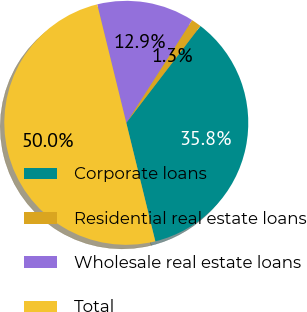Convert chart to OTSL. <chart><loc_0><loc_0><loc_500><loc_500><pie_chart><fcel>Corporate loans<fcel>Residential real estate loans<fcel>Wholesale real estate loans<fcel>Total<nl><fcel>35.78%<fcel>1.33%<fcel>12.9%<fcel>50.0%<nl></chart> 